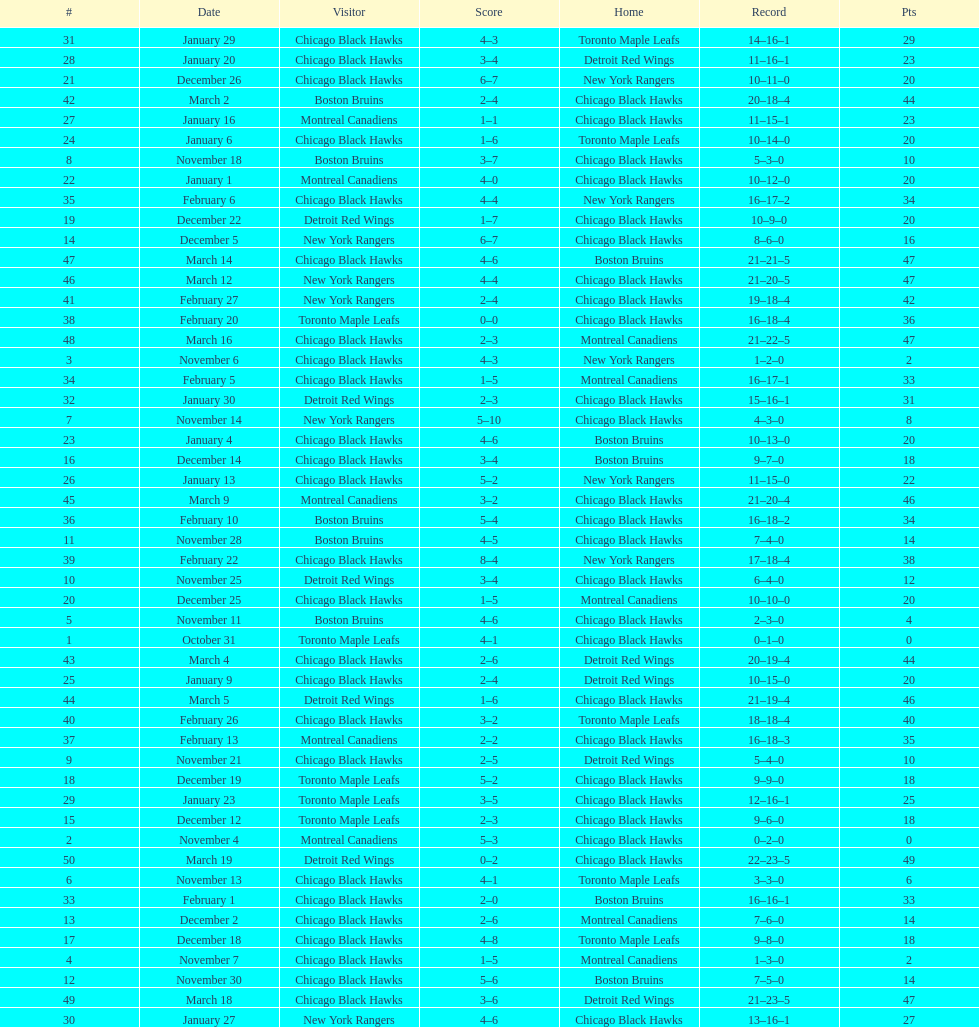Which team was the first one the black hawks lost to? Toronto Maple Leafs. 